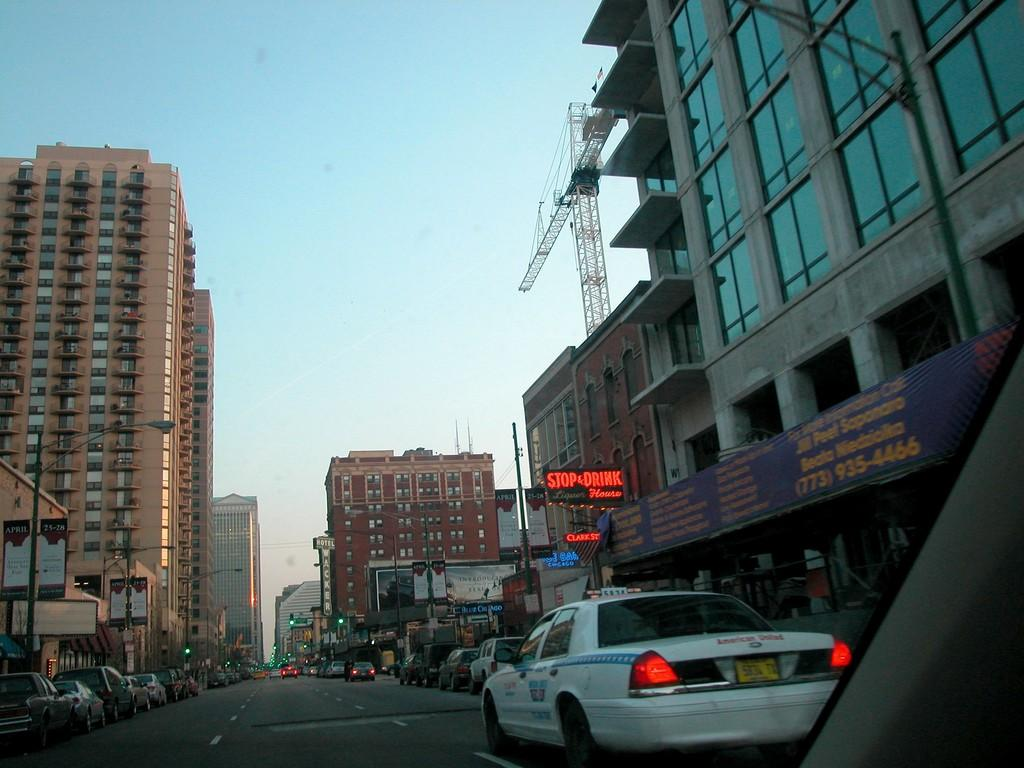Provide a one-sentence caption for the provided image. A taxi driving near a Stop and Drink house restaurant. 